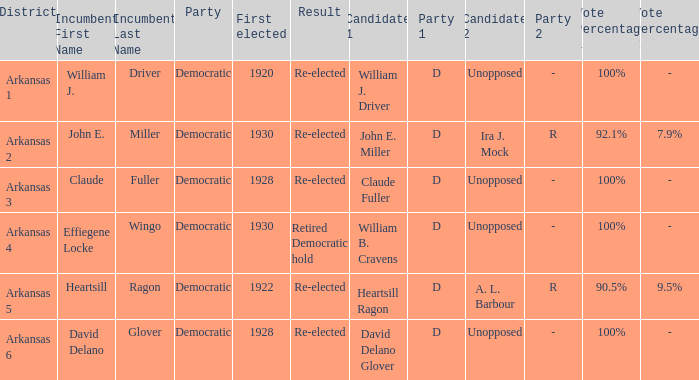In what district was John E. Miller the incumbent?  Arkansas 2. 